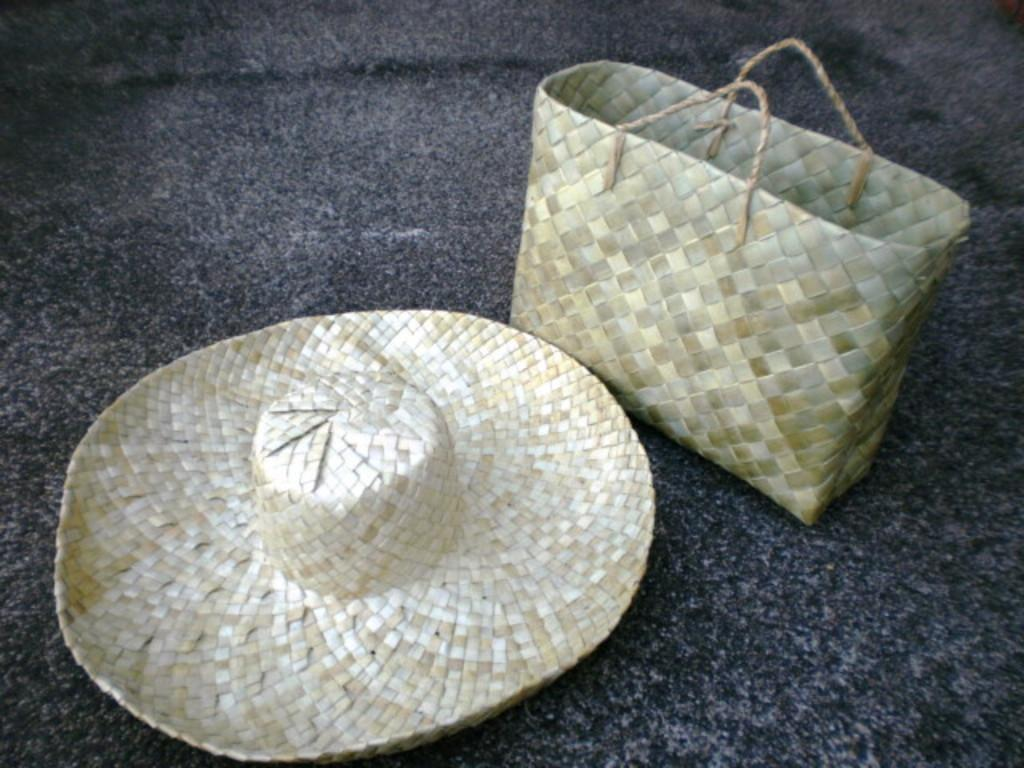What type of hat is in the image? The hat in the image is made up of dried leaves. What else is made up of dried leaves in the image? The basket in the image is also made up of dried leaves. Where are the hat and basket located in the image? Both the hat and basket are on the ground in the image. In which direction is the substance moving in the image? There is no substance moving in the image, as the hat and basket are stationary on the ground. What type of war is depicted in the image? There is no war depicted in the image; it features a hat and basket made of dried leaves on the ground. 